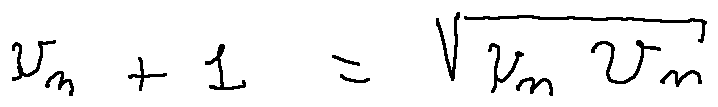Convert formula to latex. <formula><loc_0><loc_0><loc_500><loc_500>u _ { n + 1 } = \sqrt { u _ { n } v _ { n } }</formula> 